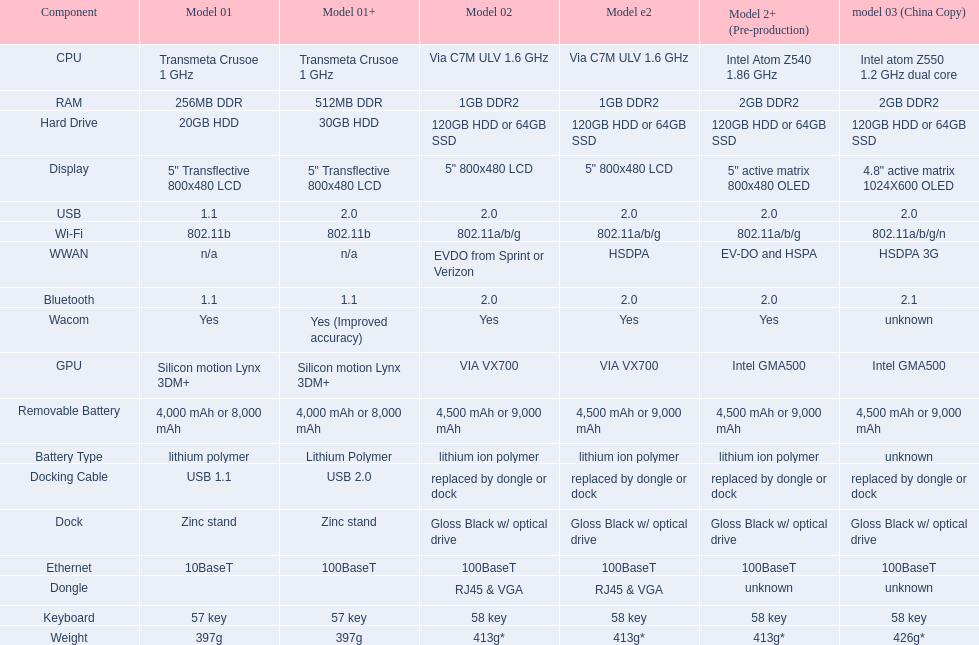What is the number of models with a 2. 